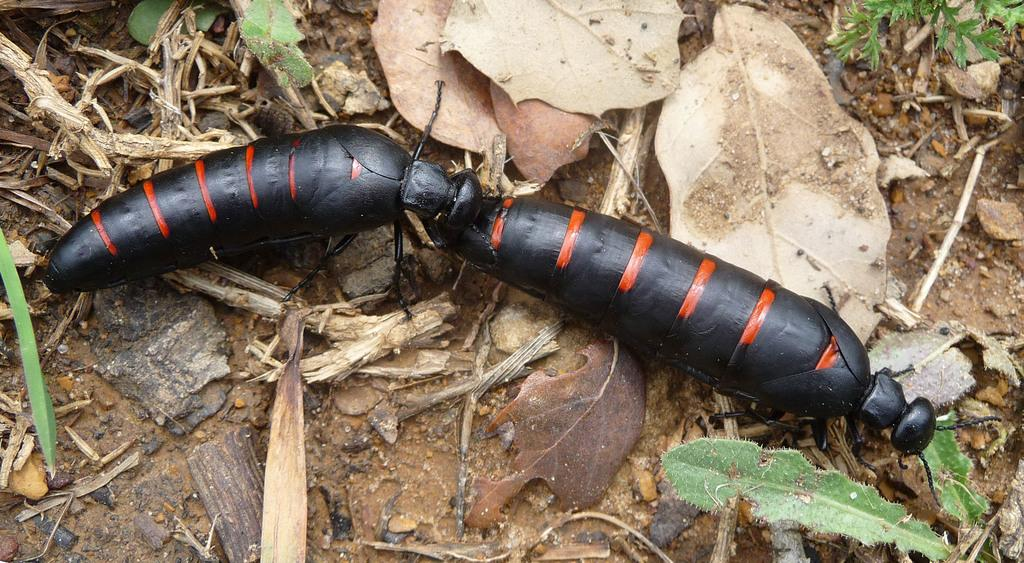What type of natural debris can be seen in the image? There are dry leaves in the image. What other living organisms are present in the image? There are insects in the image. What type of soap is being used by the insects in the image? There is no soap present in the image, as it features dry leaves and insects. What kind of music can be heard playing in the background of the image? There is no music present in the image, as it only features dry leaves and insects. 